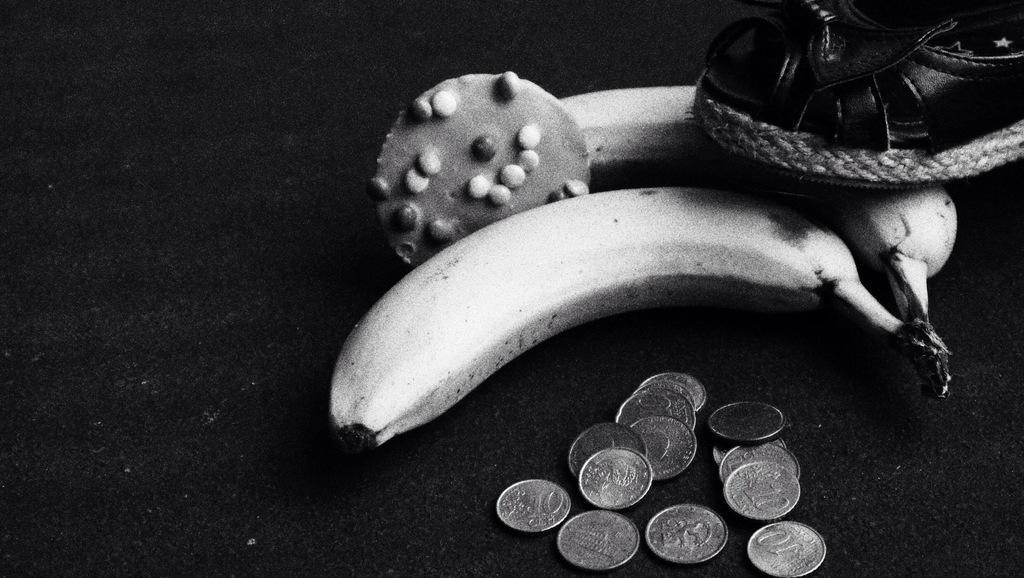Describe this image in one or two sentences. This is a zoomed in picture. In the foreground we can see the currency coins, sandal, two bananas and some other items are placed on the top of an object seems to be the table. 